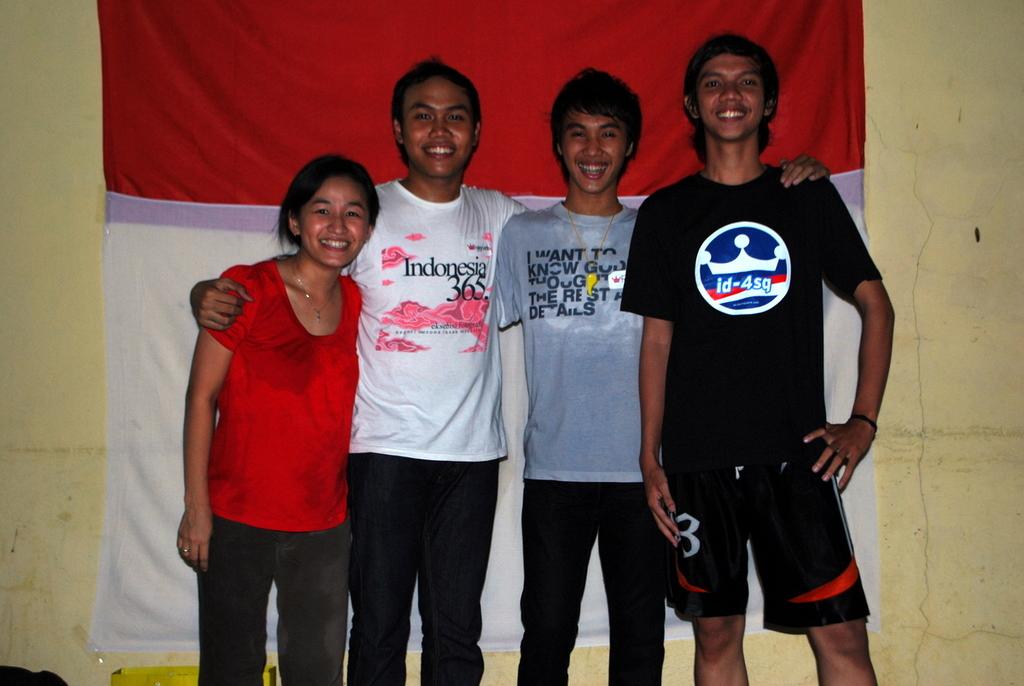What is one of the words shown on the grey shirt?
Your response must be concise. Want. 